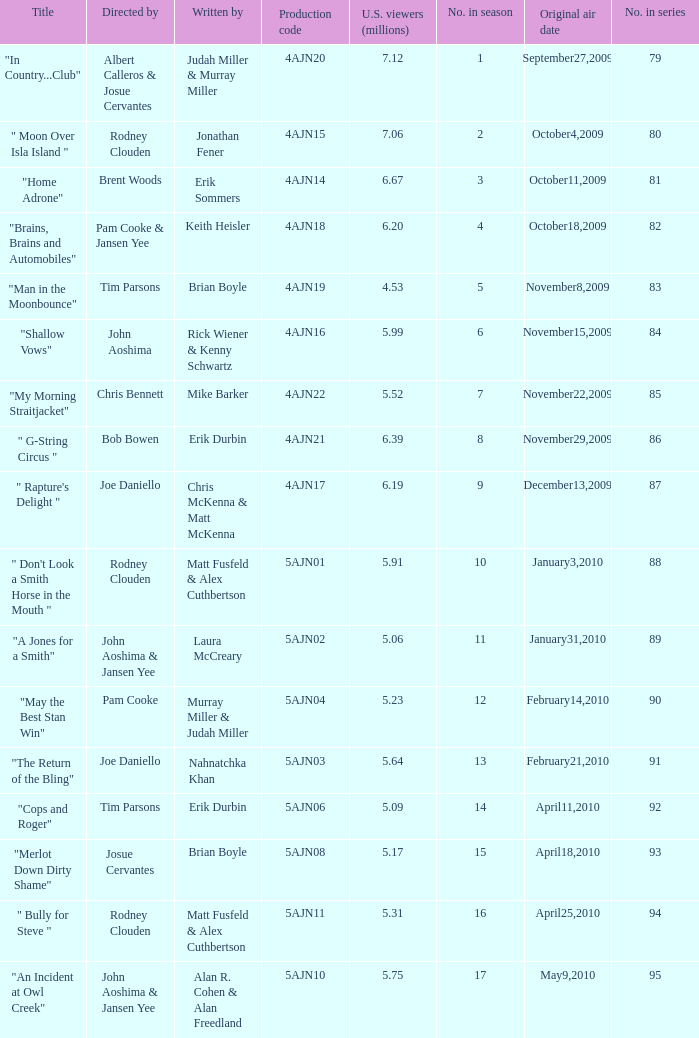Name who wrote 5ajn11 Matt Fusfeld & Alex Cuthbertson. 